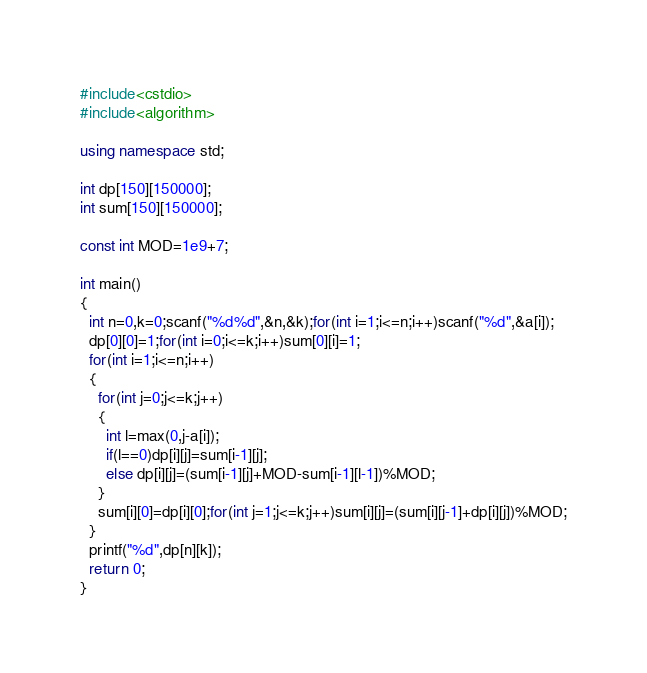<code> <loc_0><loc_0><loc_500><loc_500><_C++_>#include<cstdio>
#include<algorithm>

using namespace std;

int dp[150][150000];
int sum[150][150000];

const int MOD=1e9+7;

int main()
{
  int n=0,k=0;scanf("%d%d",&n,&k);for(int i=1;i<=n;i++)scanf("%d",&a[i]);
  dp[0][0]=1;for(int i=0;i<=k;i++)sum[0][i]=1;
  for(int i=1;i<=n;i++)
  {
    for(int j=0;j<=k;j++)
    {
      int l=max(0,j-a[i]);
      if(l==0)dp[i][j]=sum[i-1][j];
      else dp[i][j]=(sum[i-1][j]+MOD-sum[i-1][l-1])%MOD;
    }
    sum[i][0]=dp[i][0];for(int j=1;j<=k;j++)sum[i][j]=(sum[i][j-1]+dp[i][j])%MOD;
  }
  printf("%d",dp[n][k]);
  return 0;
}</code> 